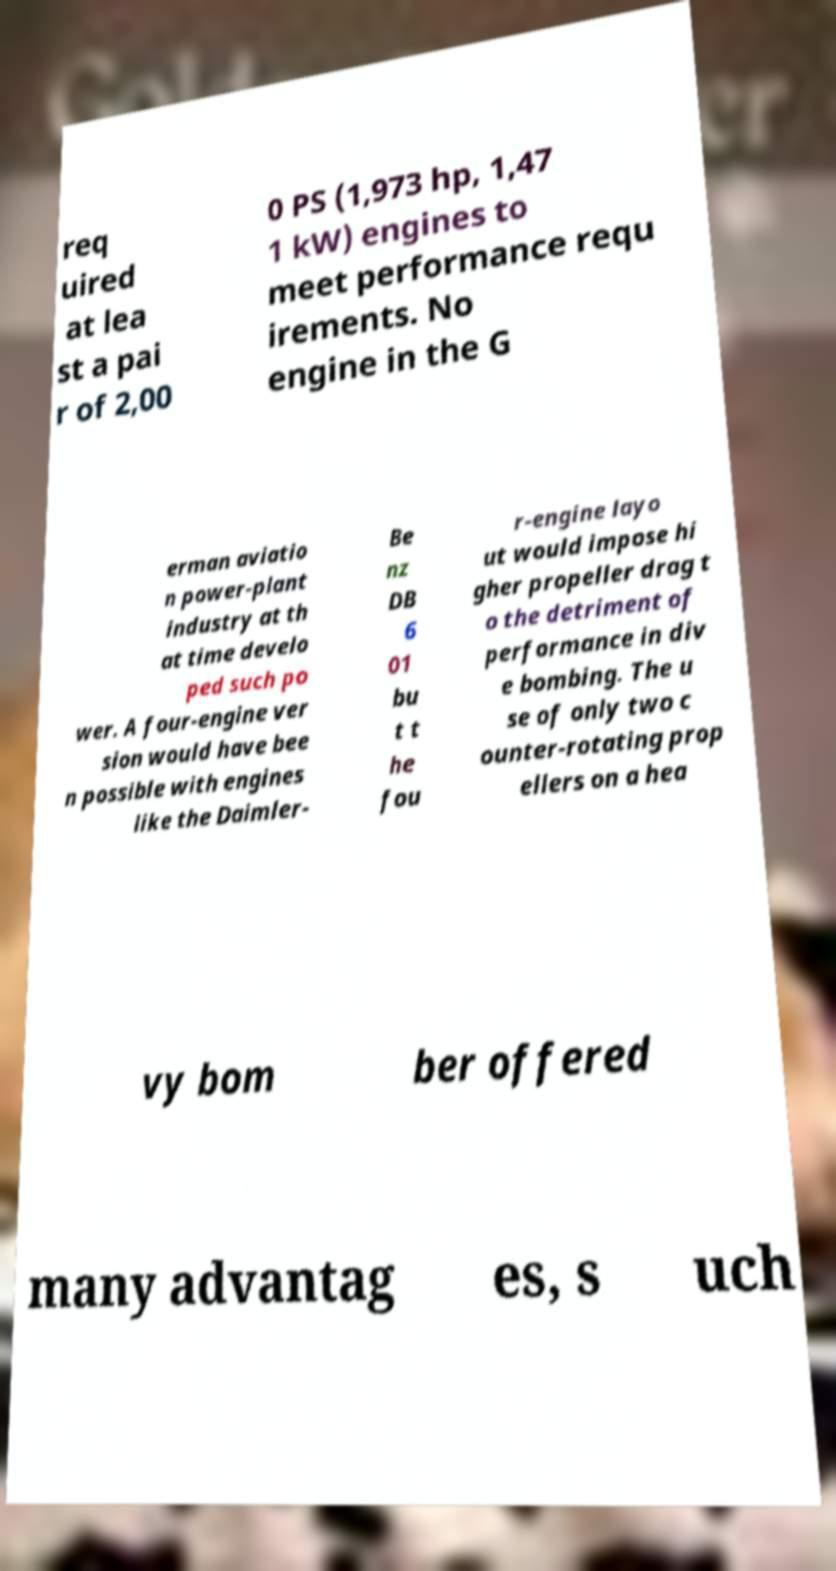For documentation purposes, I need the text within this image transcribed. Could you provide that? req uired at lea st a pai r of 2,00 0 PS (1,973 hp, 1,47 1 kW) engines to meet performance requ irements. No engine in the G erman aviatio n power-plant industry at th at time develo ped such po wer. A four-engine ver sion would have bee n possible with engines like the Daimler- Be nz DB 6 01 bu t t he fou r-engine layo ut would impose hi gher propeller drag t o the detriment of performance in div e bombing. The u se of only two c ounter-rotating prop ellers on a hea vy bom ber offered many advantag es, s uch 